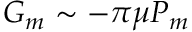Convert formula to latex. <formula><loc_0><loc_0><loc_500><loc_500>G _ { m } \sim - \pi \mu P _ { m }</formula> 